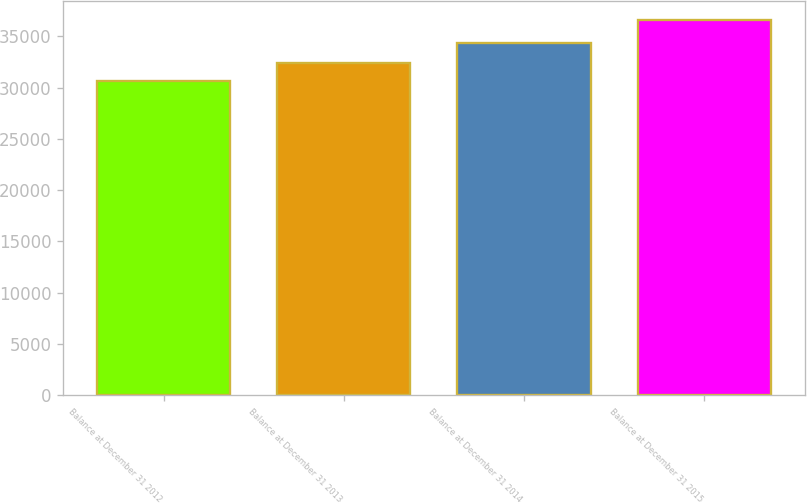Convert chart to OTSL. <chart><loc_0><loc_0><loc_500><loc_500><bar_chart><fcel>Balance at December 31 2012<fcel>Balance at December 31 2013<fcel>Balance at December 31 2014<fcel>Balance at December 31 2015<nl><fcel>30679<fcel>32416<fcel>34317<fcel>36575<nl></chart> 